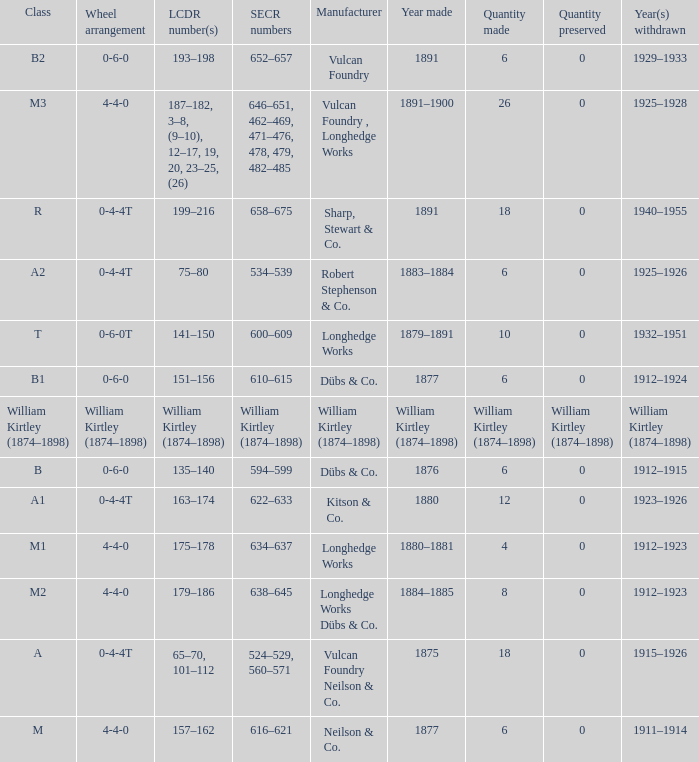Which class was made in 1880? A1. 